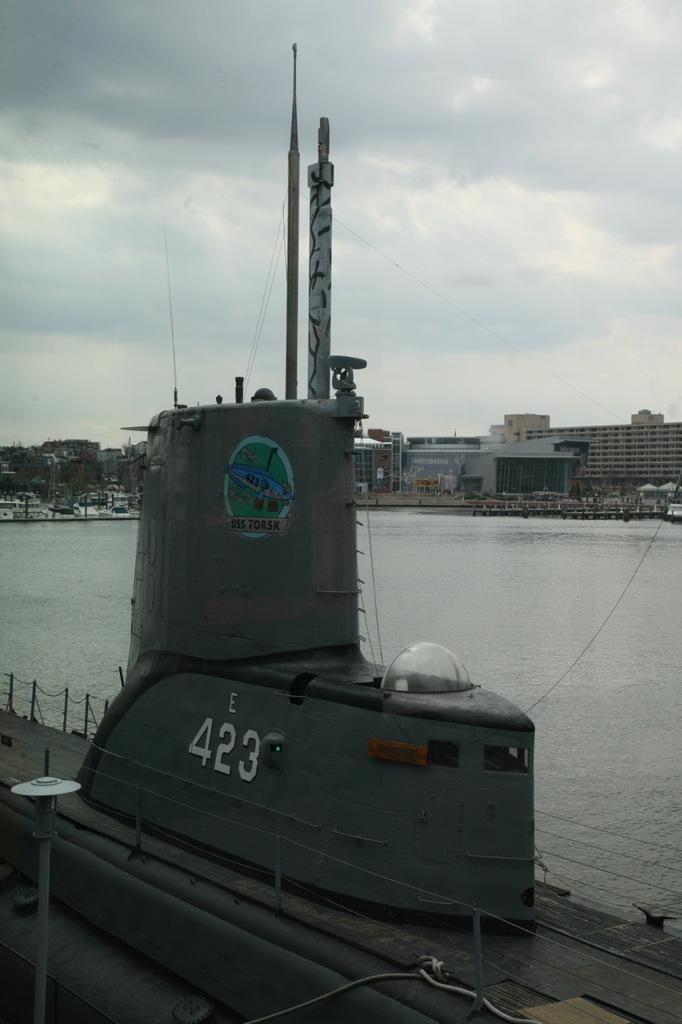Please provide a concise description of this image. In this picture I can see there is a submarine and there is water in the backdrop and there are buildings and buildings and the sky is clear. 